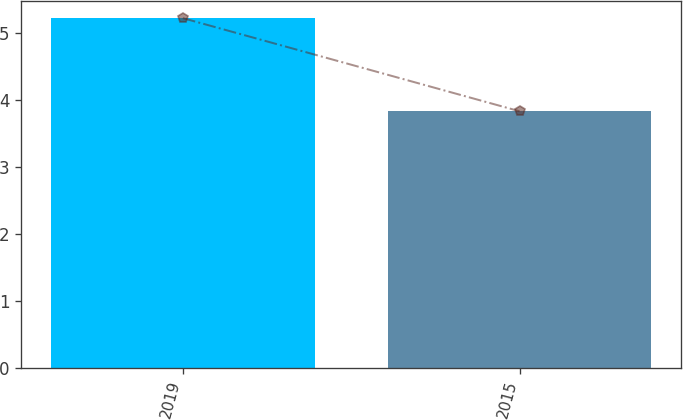Convert chart to OTSL. <chart><loc_0><loc_0><loc_500><loc_500><bar_chart><fcel>2019<fcel>2015<nl><fcel>5.22<fcel>3.83<nl></chart> 